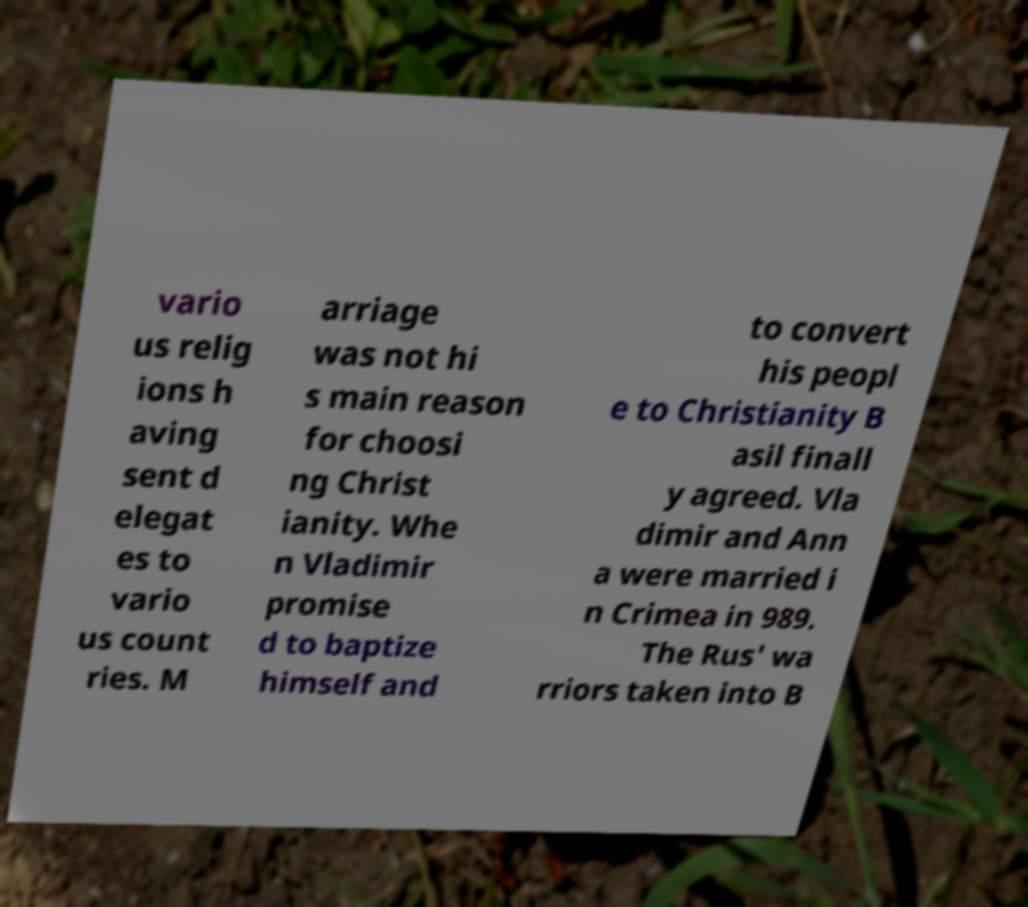Please identify and transcribe the text found in this image. vario us relig ions h aving sent d elegat es to vario us count ries. M arriage was not hi s main reason for choosi ng Christ ianity. Whe n Vladimir promise d to baptize himself and to convert his peopl e to Christianity B asil finall y agreed. Vla dimir and Ann a were married i n Crimea in 989. The Rus' wa rriors taken into B 